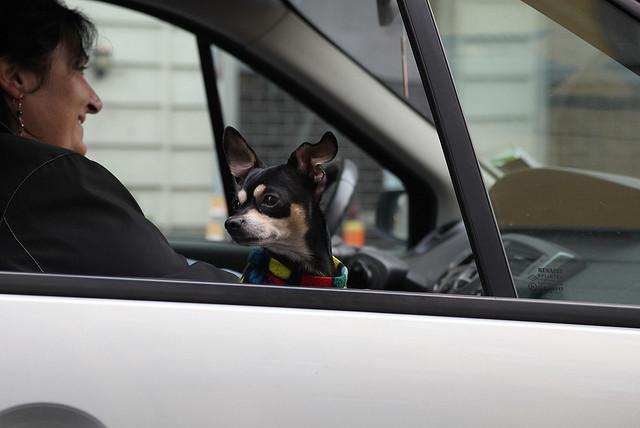What color is the car?
Quick response, please. White. What kind of dog is this?
Keep it brief. Chihuahua. Is the woman smiling?
Quick response, please. Yes. 